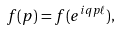Convert formula to latex. <formula><loc_0><loc_0><loc_500><loc_500>f ( p ) = f ( e ^ { i q p \ell } ) ,</formula> 